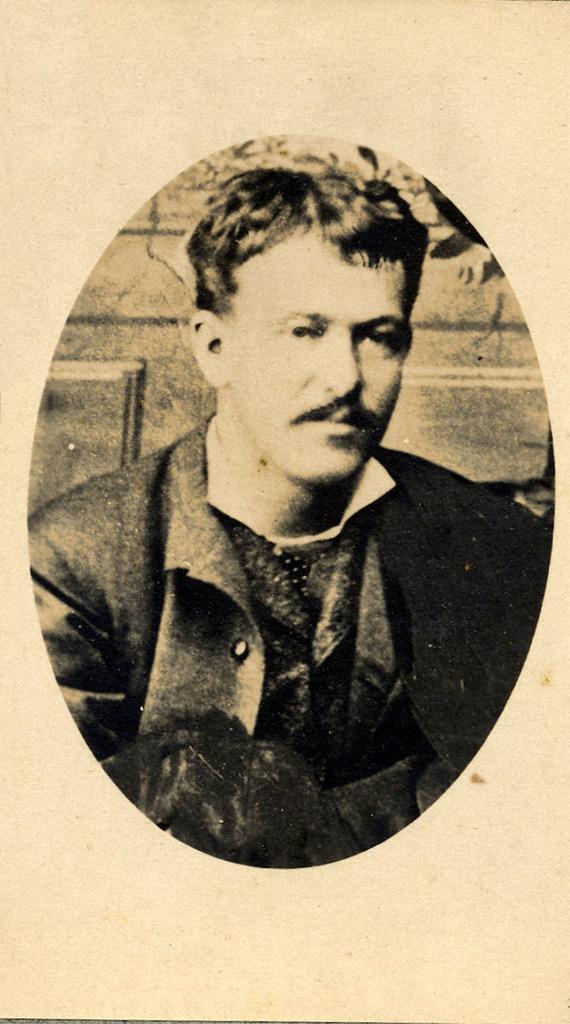What is present in the image that features a visual representation? There is a poster in the image. What is depicted on the poster? The poster contains a photo of a man. What can be observed about the man in the photo? The man in the photo is wearing clothes. What type of chalk is the man holding in the photo on the poster? There is no chalk present in the photo on the poster; the man is simply wearing clothes. Can you see any nuts in the photo on the poster? There are no nuts visible in the photo on the poster; it only features a man wearing clothes. 